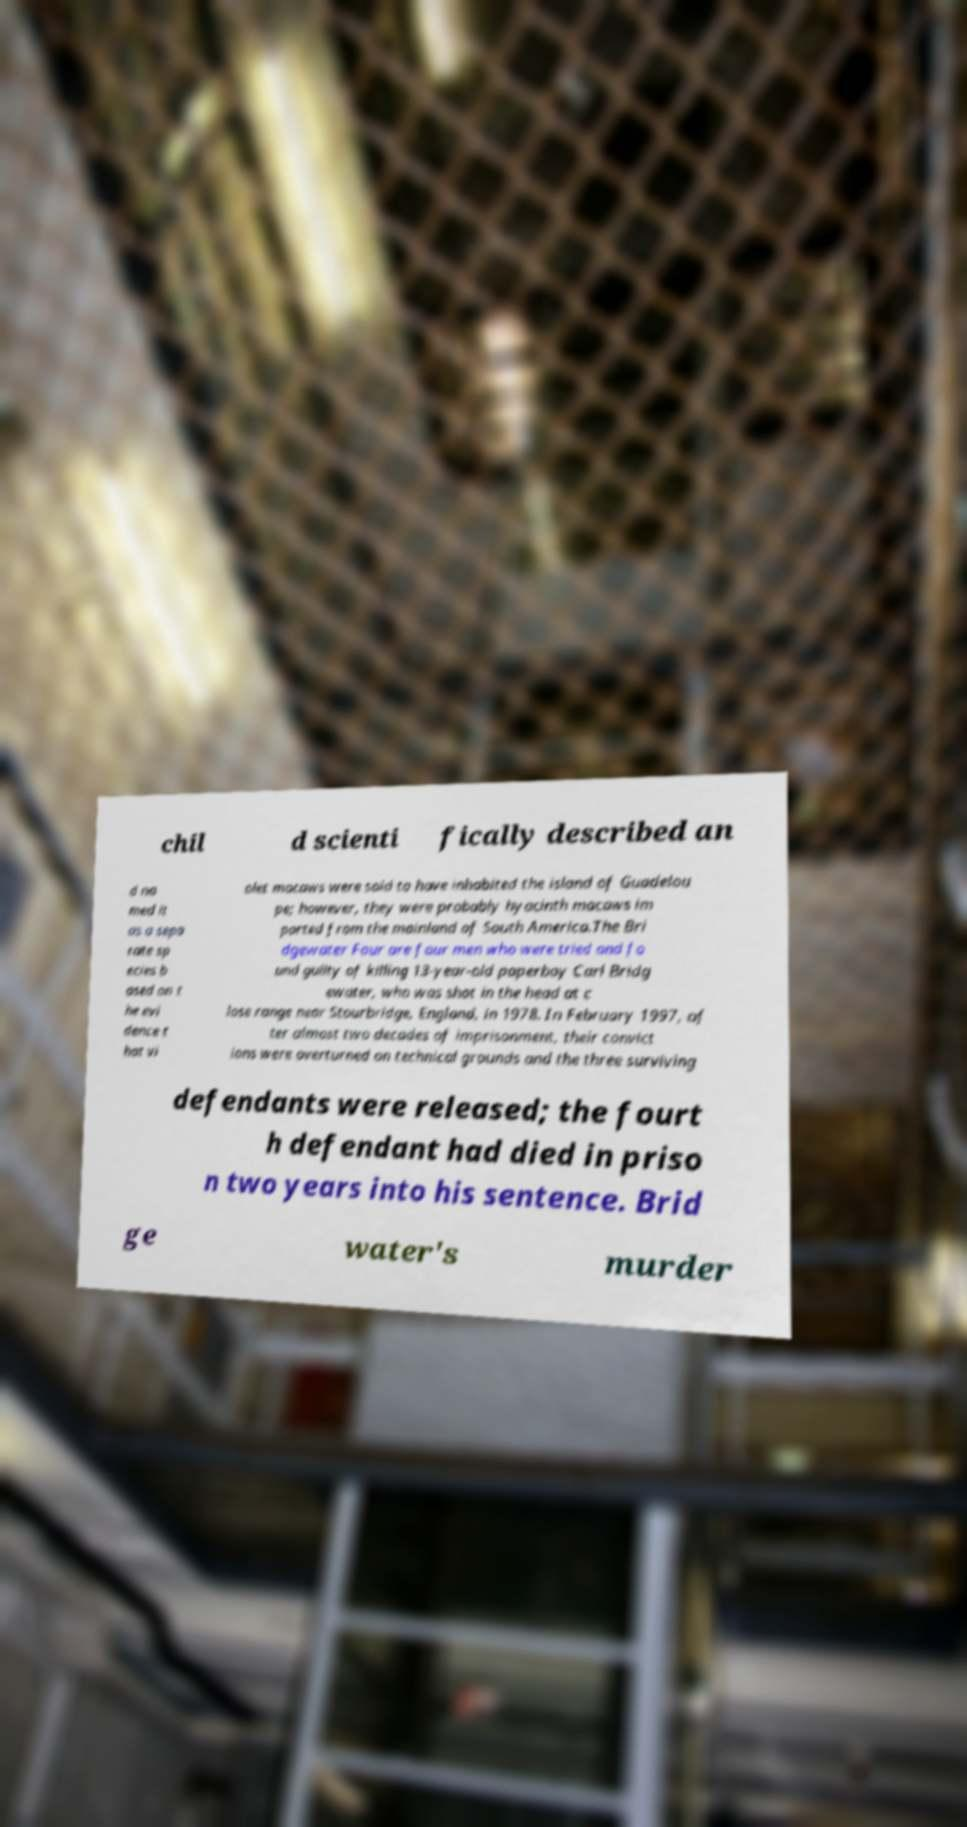Can you read and provide the text displayed in the image?This photo seems to have some interesting text. Can you extract and type it out for me? chil d scienti fically described an d na med it as a sepa rate sp ecies b ased on t he evi dence t hat vi olet macaws were said to have inhabited the island of Guadelou pe; however, they were probably hyacinth macaws im ported from the mainland of South America.The Bri dgewater Four are four men who were tried and fo und guilty of killing 13-year-old paperboy Carl Bridg ewater, who was shot in the head at c lose range near Stourbridge, England, in 1978. In February 1997, af ter almost two decades of imprisonment, their convict ions were overturned on technical grounds and the three surviving defendants were released; the fourt h defendant had died in priso n two years into his sentence. Brid ge water's murder 